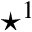Convert formula to latex. <formula><loc_0><loc_0><loc_500><loc_500>^ { * } ^ { 1 }</formula> 